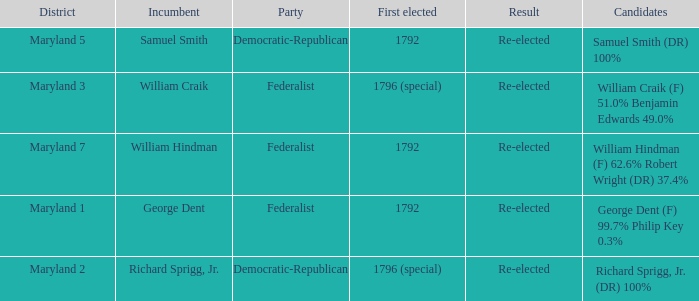Who is the candidates for district maryland 1? George Dent (F) 99.7% Philip Key 0.3%. 